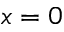<formula> <loc_0><loc_0><loc_500><loc_500>x = 0</formula> 